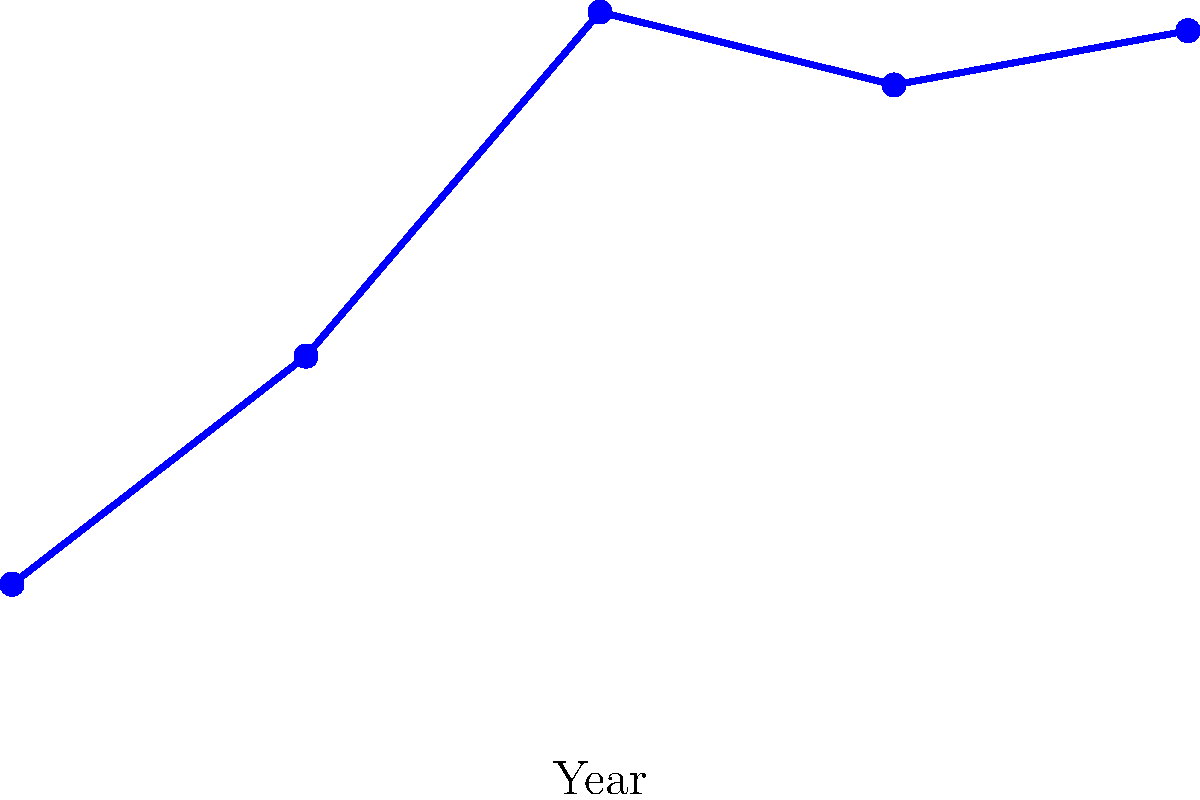Based on the line graph depicting Russia's GDP growth from 2000 to 2020, which period showed the most significant economic volatility, and what geopolitical factors might have contributed to this trend? To answer this question, we need to analyze the graph and consider the geopolitical context:

1. Observe the overall trend: The graph shows Russia's GDP growth from 2000 to 2020, measured in billion USD.

2. Identify periods of volatility: The most significant volatility appears to be between 2010 and 2020.

3. Analyze the specific period:
   a. From 2010 to 2015, there's a sharp decline in GDP.
   b. From 2015 to 2020, there's a moderate recovery.

4. Consider geopolitical factors during this period:
   a. 2014: Russia annexed Crimea, leading to international sanctions.
   b. 2014-2015: Global oil prices dropped significantly, affecting Russia's oil-dependent economy.
   c. 2014-onwards: Ongoing tensions with the West, including escalated sanctions.

5. Connect the economic trend to geopolitical events:
   The sharp decline from 2010 to 2015 coincides with the Crimean annexation, resulting sanctions, and the oil price drop. These factors likely contributed to the economic downturn.

6. Assess the recovery:
   The moderate recovery from 2015 to 2020 might indicate Russia's adaptation to sanctions and a slight rebound in oil prices.

Therefore, the period of 2010-2020 showed the most significant economic volatility, largely influenced by the geopolitical factors surrounding the Crimean annexation and its aftermath.
Answer: 2010-2020; Crimean annexation, sanctions, oil price fluctuations 